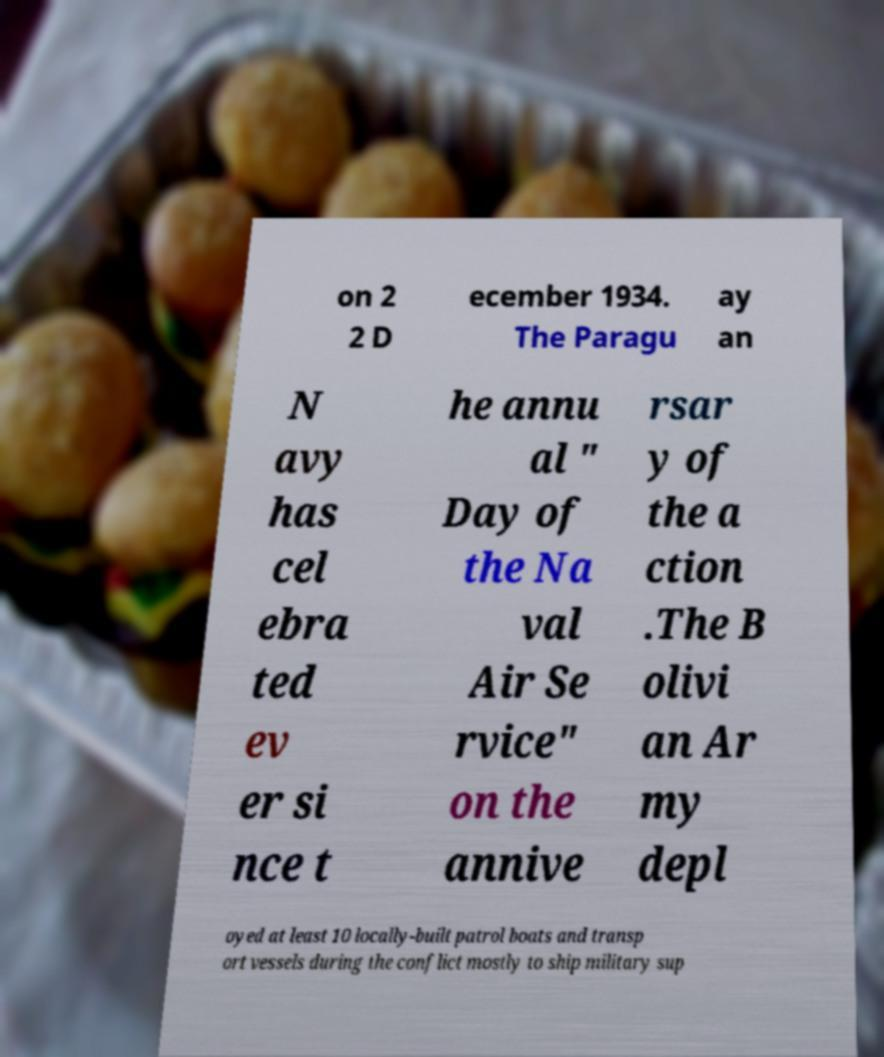Can you read and provide the text displayed in the image?This photo seems to have some interesting text. Can you extract and type it out for me? on 2 2 D ecember 1934. The Paragu ay an N avy has cel ebra ted ev er si nce t he annu al " Day of the Na val Air Se rvice" on the annive rsar y of the a ction .The B olivi an Ar my depl oyed at least 10 locally-built patrol boats and transp ort vessels during the conflict mostly to ship military sup 